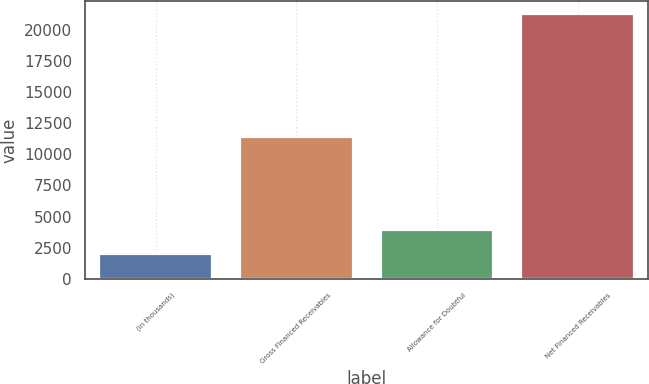Convert chart. <chart><loc_0><loc_0><loc_500><loc_500><bar_chart><fcel>(in thousands)<fcel>Gross Financed Receivables<fcel>Allowance for Doubtful<fcel>Net Financed Receivables<nl><fcel>2010<fcel>11362<fcel>3932.7<fcel>21237<nl></chart> 